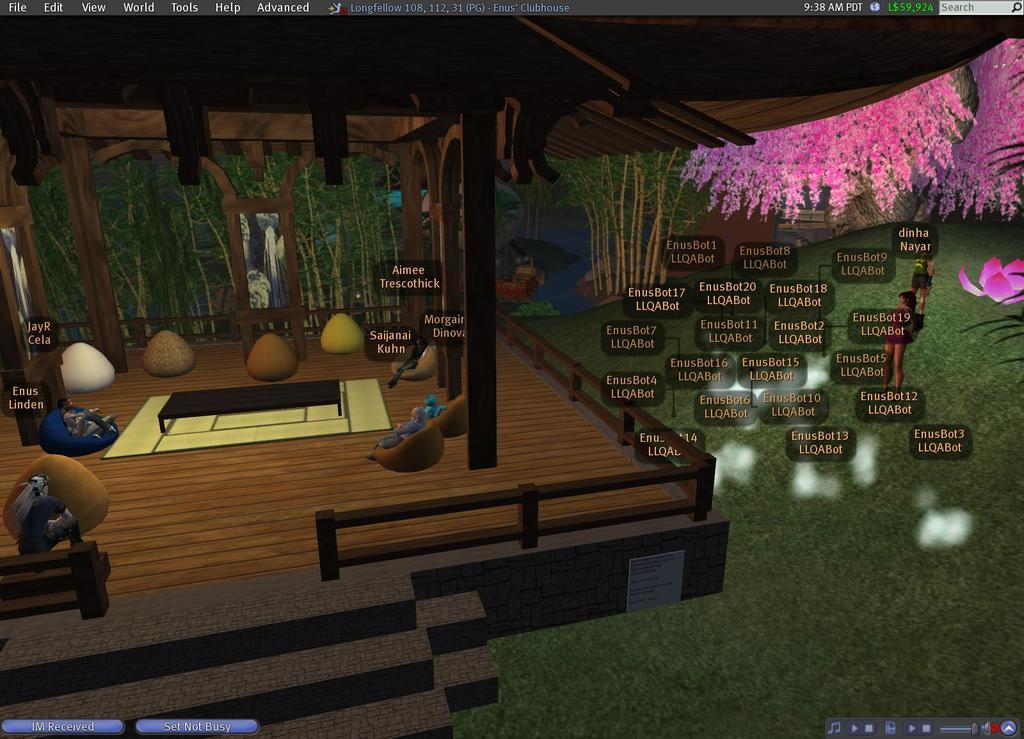What is on the floor in the image? There are objects on the floor in the image. What can be seen in addition to the objects on the floor? There is text, flowers, trees, and grass in the image. What is the maid discussing with the lock in the image? There is no maid or lock present in the image. 